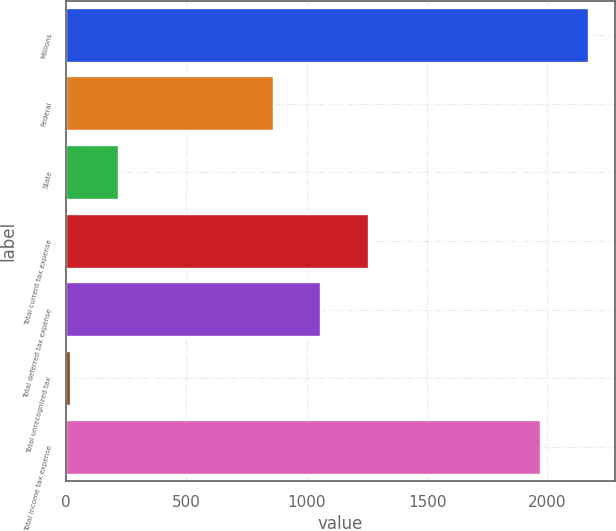Convert chart to OTSL. <chart><loc_0><loc_0><loc_500><loc_500><bar_chart><fcel>Millions<fcel>Federal<fcel>State<fcel>Total current tax expense<fcel>Total deferred tax expense<fcel>Total unrecognized tax<fcel>Total income tax expense<nl><fcel>2170.9<fcel>862<fcel>220.9<fcel>1259.8<fcel>1060.9<fcel>22<fcel>1972<nl></chart> 